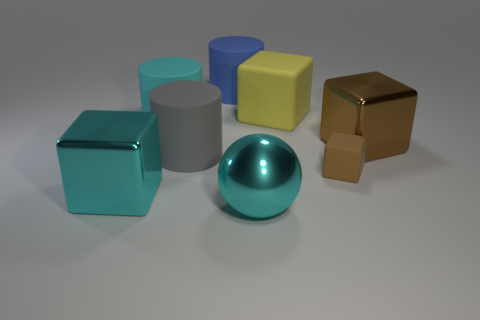Add 2 matte cylinders. How many objects exist? 10 Subtract all cylinders. How many objects are left? 5 Add 5 brown matte blocks. How many brown matte blocks exist? 6 Subtract 0 brown cylinders. How many objects are left? 8 Subtract all big rubber cylinders. Subtract all yellow blocks. How many objects are left? 4 Add 6 big yellow things. How many big yellow things are left? 7 